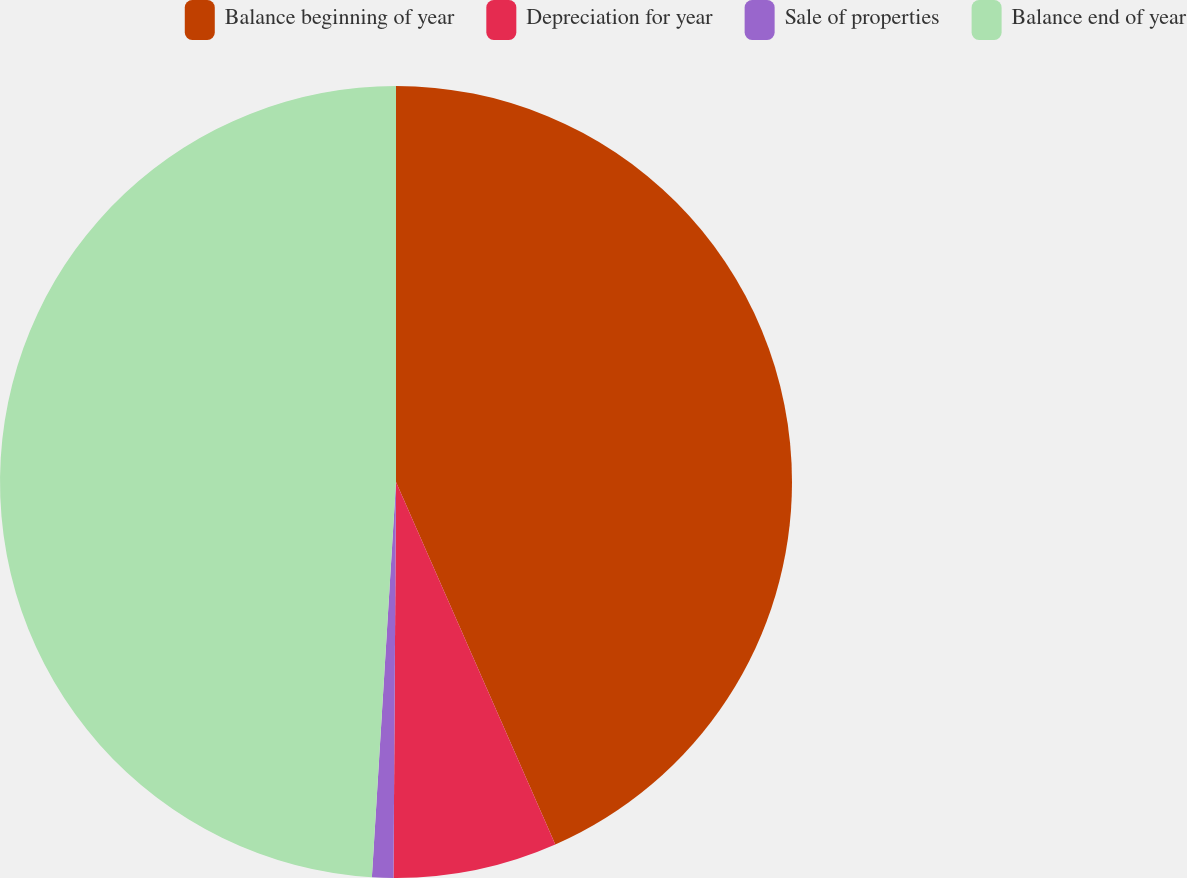Convert chart. <chart><loc_0><loc_0><loc_500><loc_500><pie_chart><fcel>Balance beginning of year<fcel>Depreciation for year<fcel>Sale of properties<fcel>Balance end of year<nl><fcel>43.41%<fcel>6.69%<fcel>0.87%<fcel>49.03%<nl></chart> 